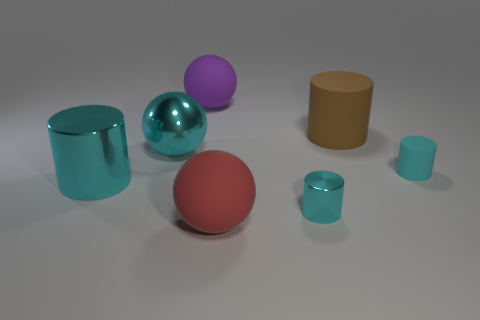What is the size of the matte object that is the same color as the tiny metallic cylinder?
Your response must be concise. Small. Are there more large spheres behind the brown cylinder than big matte cylinders that are left of the large purple thing?
Give a very brief answer. Yes. What number of large metallic balls have the same color as the tiny shiny thing?
Keep it short and to the point. 1. What is the size of the brown thing that is made of the same material as the big red ball?
Provide a short and direct response. Large. How many things are small cyan cylinders behind the big cyan cylinder or big brown objects?
Make the answer very short. 2. Does the big shiny object that is in front of the large cyan metallic sphere have the same color as the tiny metallic cylinder?
Your answer should be compact. Yes. There is a cyan matte thing that is the same shape as the small cyan shiny thing; what size is it?
Ensure brevity in your answer.  Small. What color is the matte ball in front of the purple matte ball left of the cyan metal cylinder that is on the right side of the large red matte sphere?
Give a very brief answer. Red. Is the material of the cyan ball the same as the red thing?
Your answer should be very brief. No. There is a rubber ball that is in front of the big matte thing right of the red object; are there any large matte things behind it?
Your answer should be very brief. Yes. 